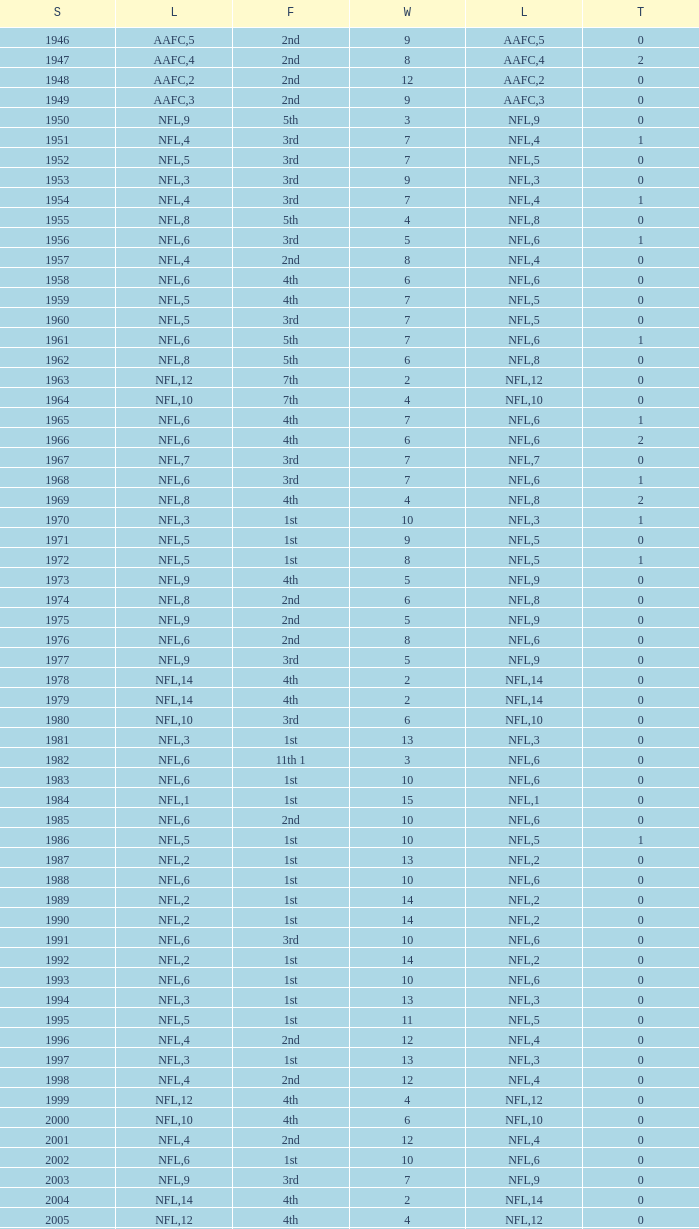What is the losses in the NFL in the 2011 season with less than 13 wins? None. 